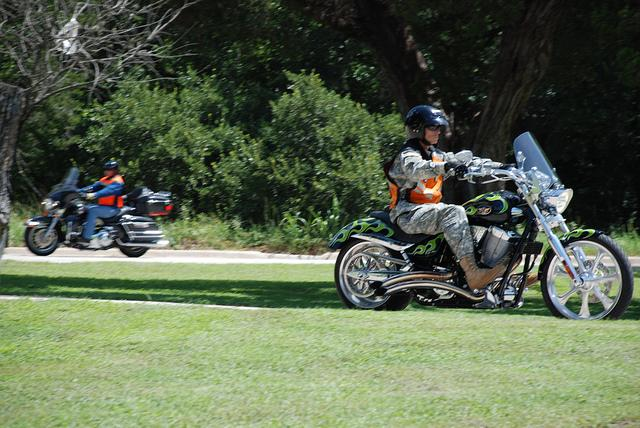The man riding the motorcycle is involved in what type of public service?

Choices:
A) police
B) medical
C) fire safety
D) military military 